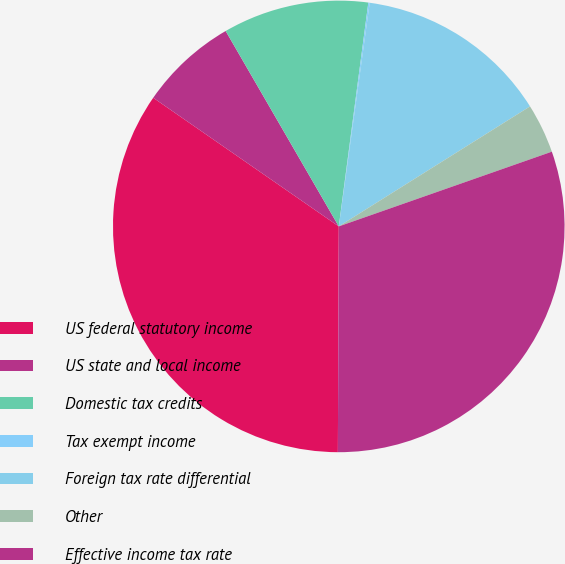Convert chart to OTSL. <chart><loc_0><loc_0><loc_500><loc_500><pie_chart><fcel>US federal statutory income<fcel>US state and local income<fcel>Domestic tax credits<fcel>Tax exempt income<fcel>Foreign tax rate differential<fcel>Other<fcel>Effective income tax rate<nl><fcel>34.58%<fcel>7.0%<fcel>10.44%<fcel>0.1%<fcel>13.89%<fcel>3.55%<fcel>30.43%<nl></chart> 